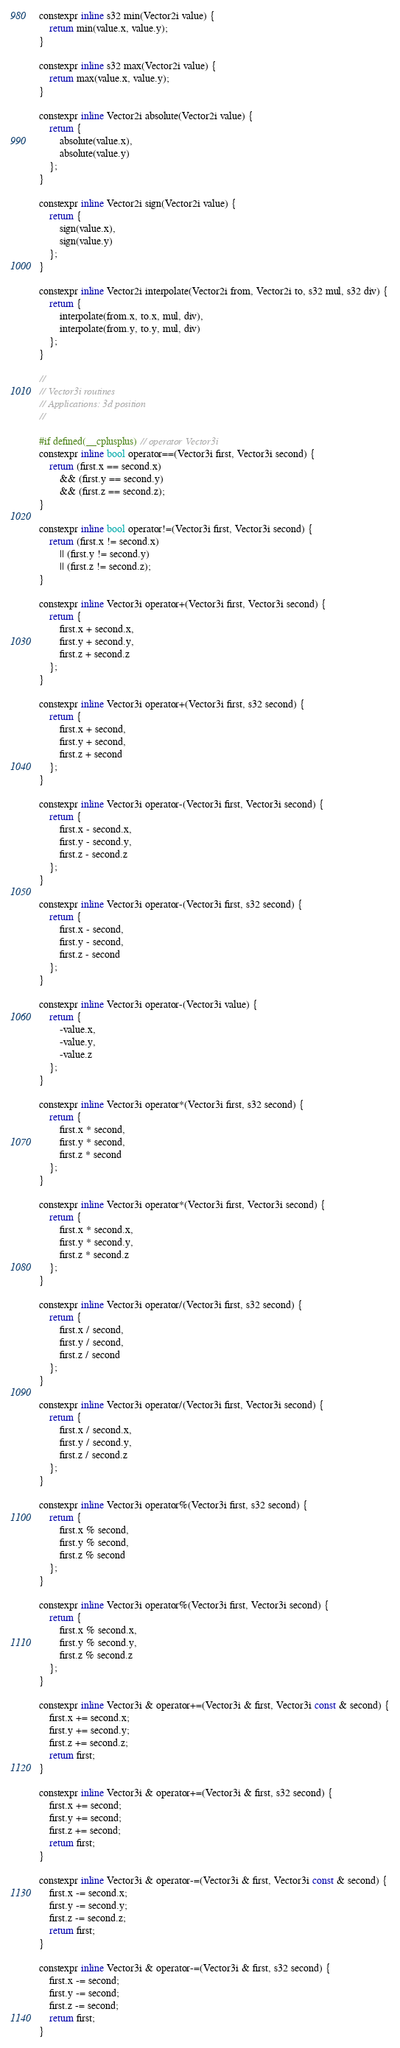<code> <loc_0><loc_0><loc_500><loc_500><_C_>
constexpr inline s32 min(Vector2i value) {
	return min(value.x, value.y);
}

constexpr inline s32 max(Vector2i value) {
	return max(value.x, value.y);
}

constexpr inline Vector2i absolute(Vector2i value) {
	return {
		absolute(value.x),
		absolute(value.y)
	};
}

constexpr inline Vector2i sign(Vector2i value) {
	return {
		sign(value.x),
		sign(value.y)
	};
}

constexpr inline Vector2i interpolate(Vector2i from, Vector2i to, s32 mul, s32 div) {
	return {
		interpolate(from.x, to.x, mul, div),
		interpolate(from.y, to.y, mul, div)
	};
}

//
// Vector3i routines
// Applications: 3d position
//

#if defined(__cplusplus) // operator Vector3i
constexpr inline bool operator==(Vector3i first, Vector3i second) {
	return (first.x == second.x)
	    && (first.y == second.y)
	    && (first.z == second.z);
}

constexpr inline bool operator!=(Vector3i first, Vector3i second) {
	return (first.x != second.x)
	    || (first.y != second.y)
	    || (first.z != second.z);
}

constexpr inline Vector3i operator+(Vector3i first, Vector3i second) {
	return {
		first.x + second.x,
		first.y + second.y,
		first.z + second.z
	};
}

constexpr inline Vector3i operator+(Vector3i first, s32 second) {
	return {
		first.x + second,
		first.y + second,
		first.z + second
	};
}

constexpr inline Vector3i operator-(Vector3i first, Vector3i second) {
	return {
		first.x - second.x,
		first.y - second.y,
		first.z - second.z
	};
}

constexpr inline Vector3i operator-(Vector3i first, s32 second) {
	return {
		first.x - second,
		first.y - second,
		first.z - second
	};
}

constexpr inline Vector3i operator-(Vector3i value) {
	return {
		-value.x,
		-value.y,
		-value.z
	};
}

constexpr inline Vector3i operator*(Vector3i first, s32 second) {
	return {
		first.x * second,
		first.y * second,
		first.z * second
	};
}

constexpr inline Vector3i operator*(Vector3i first, Vector3i second) {
	return {
		first.x * second.x,
		first.y * second.y,
		first.z * second.z
	};
}

constexpr inline Vector3i operator/(Vector3i first, s32 second) {
	return {
		first.x / second,
		first.y / second,
		first.z / second
	};
}

constexpr inline Vector3i operator/(Vector3i first, Vector3i second) {
	return {
		first.x / second.x,
		first.y / second.y,
		first.z / second.z
	};
}

constexpr inline Vector3i operator%(Vector3i first, s32 second) {
	return {
		first.x % second,
		first.y % second,
		first.z % second
	};
}

constexpr inline Vector3i operator%(Vector3i first, Vector3i second) {
	return {
		first.x % second.x,
		first.y % second.y,
		first.z % second.z
	};
}

constexpr inline Vector3i & operator+=(Vector3i & first, Vector3i const & second) {
	first.x += second.x;
	first.y += second.y;
	first.z += second.z;
	return first;
}

constexpr inline Vector3i & operator+=(Vector3i & first, s32 second) {
	first.x += second;
	first.y += second;
	first.z += second;
	return first;
}

constexpr inline Vector3i & operator-=(Vector3i & first, Vector3i const & second) {
	first.x -= second.x;
	first.y -= second.y;
	first.z -= second.z;
	return first;
}

constexpr inline Vector3i & operator-=(Vector3i & first, s32 second) {
	first.x -= second;
	first.y -= second;
	first.z -= second;
	return first;
}
</code> 